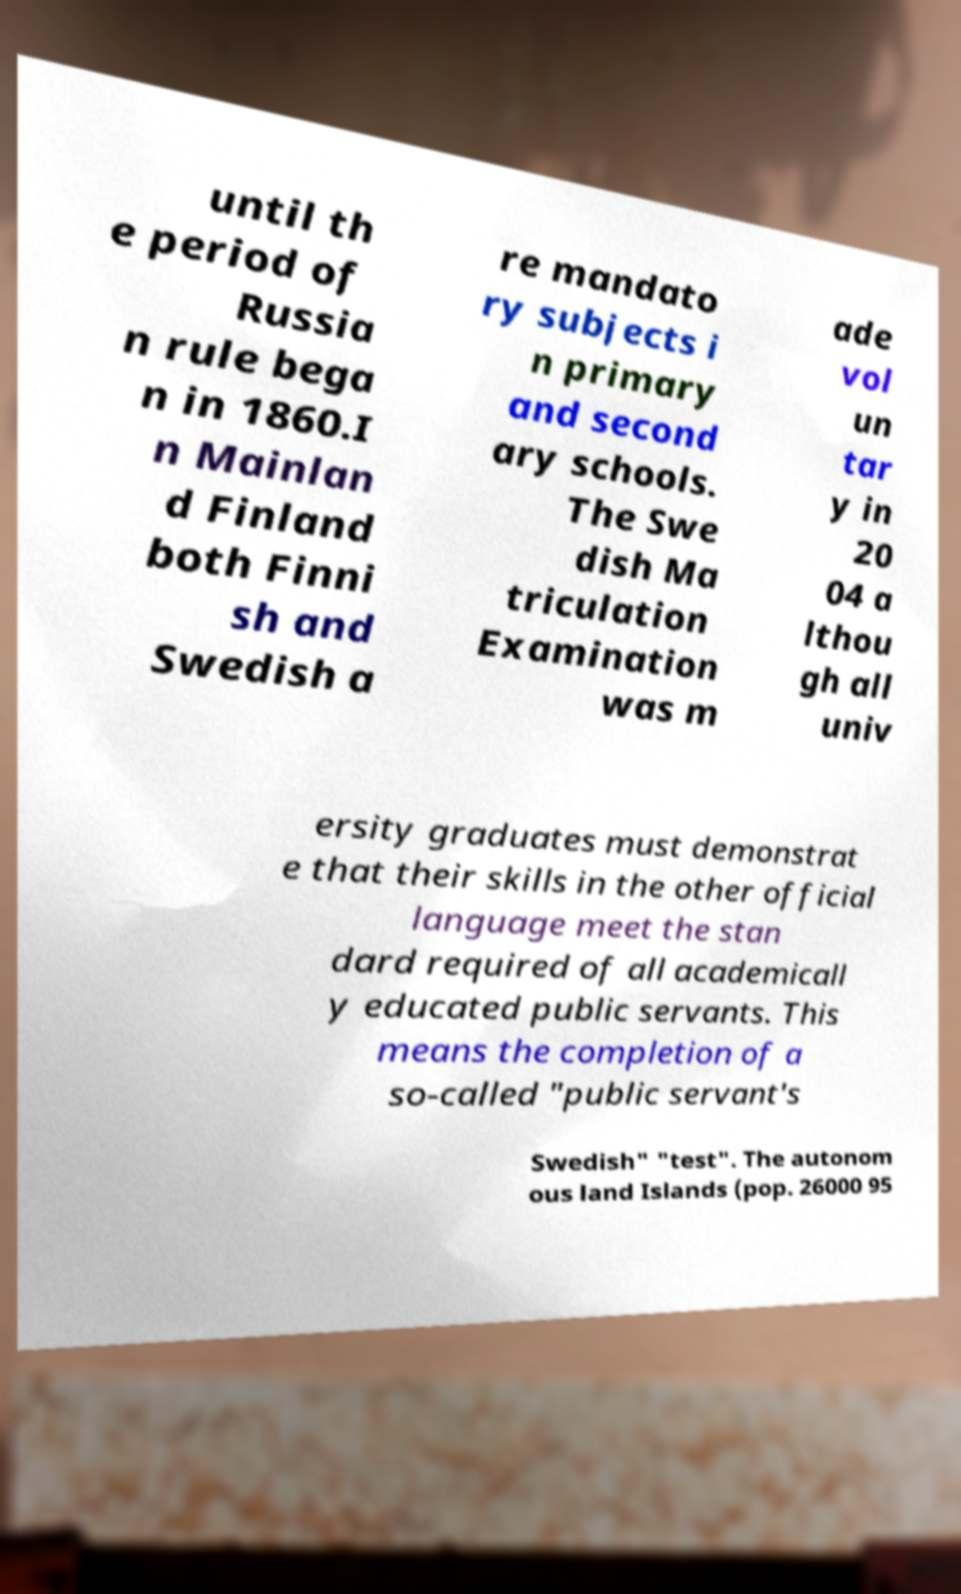What messages or text are displayed in this image? I need them in a readable, typed format. until th e period of Russia n rule bega n in 1860.I n Mainlan d Finland both Finni sh and Swedish a re mandato ry subjects i n primary and second ary schools. The Swe dish Ma triculation Examination was m ade vol un tar y in 20 04 a lthou gh all univ ersity graduates must demonstrat e that their skills in the other official language meet the stan dard required of all academicall y educated public servants. This means the completion of a so-called "public servant's Swedish" "test". The autonom ous land Islands (pop. 26000 95 